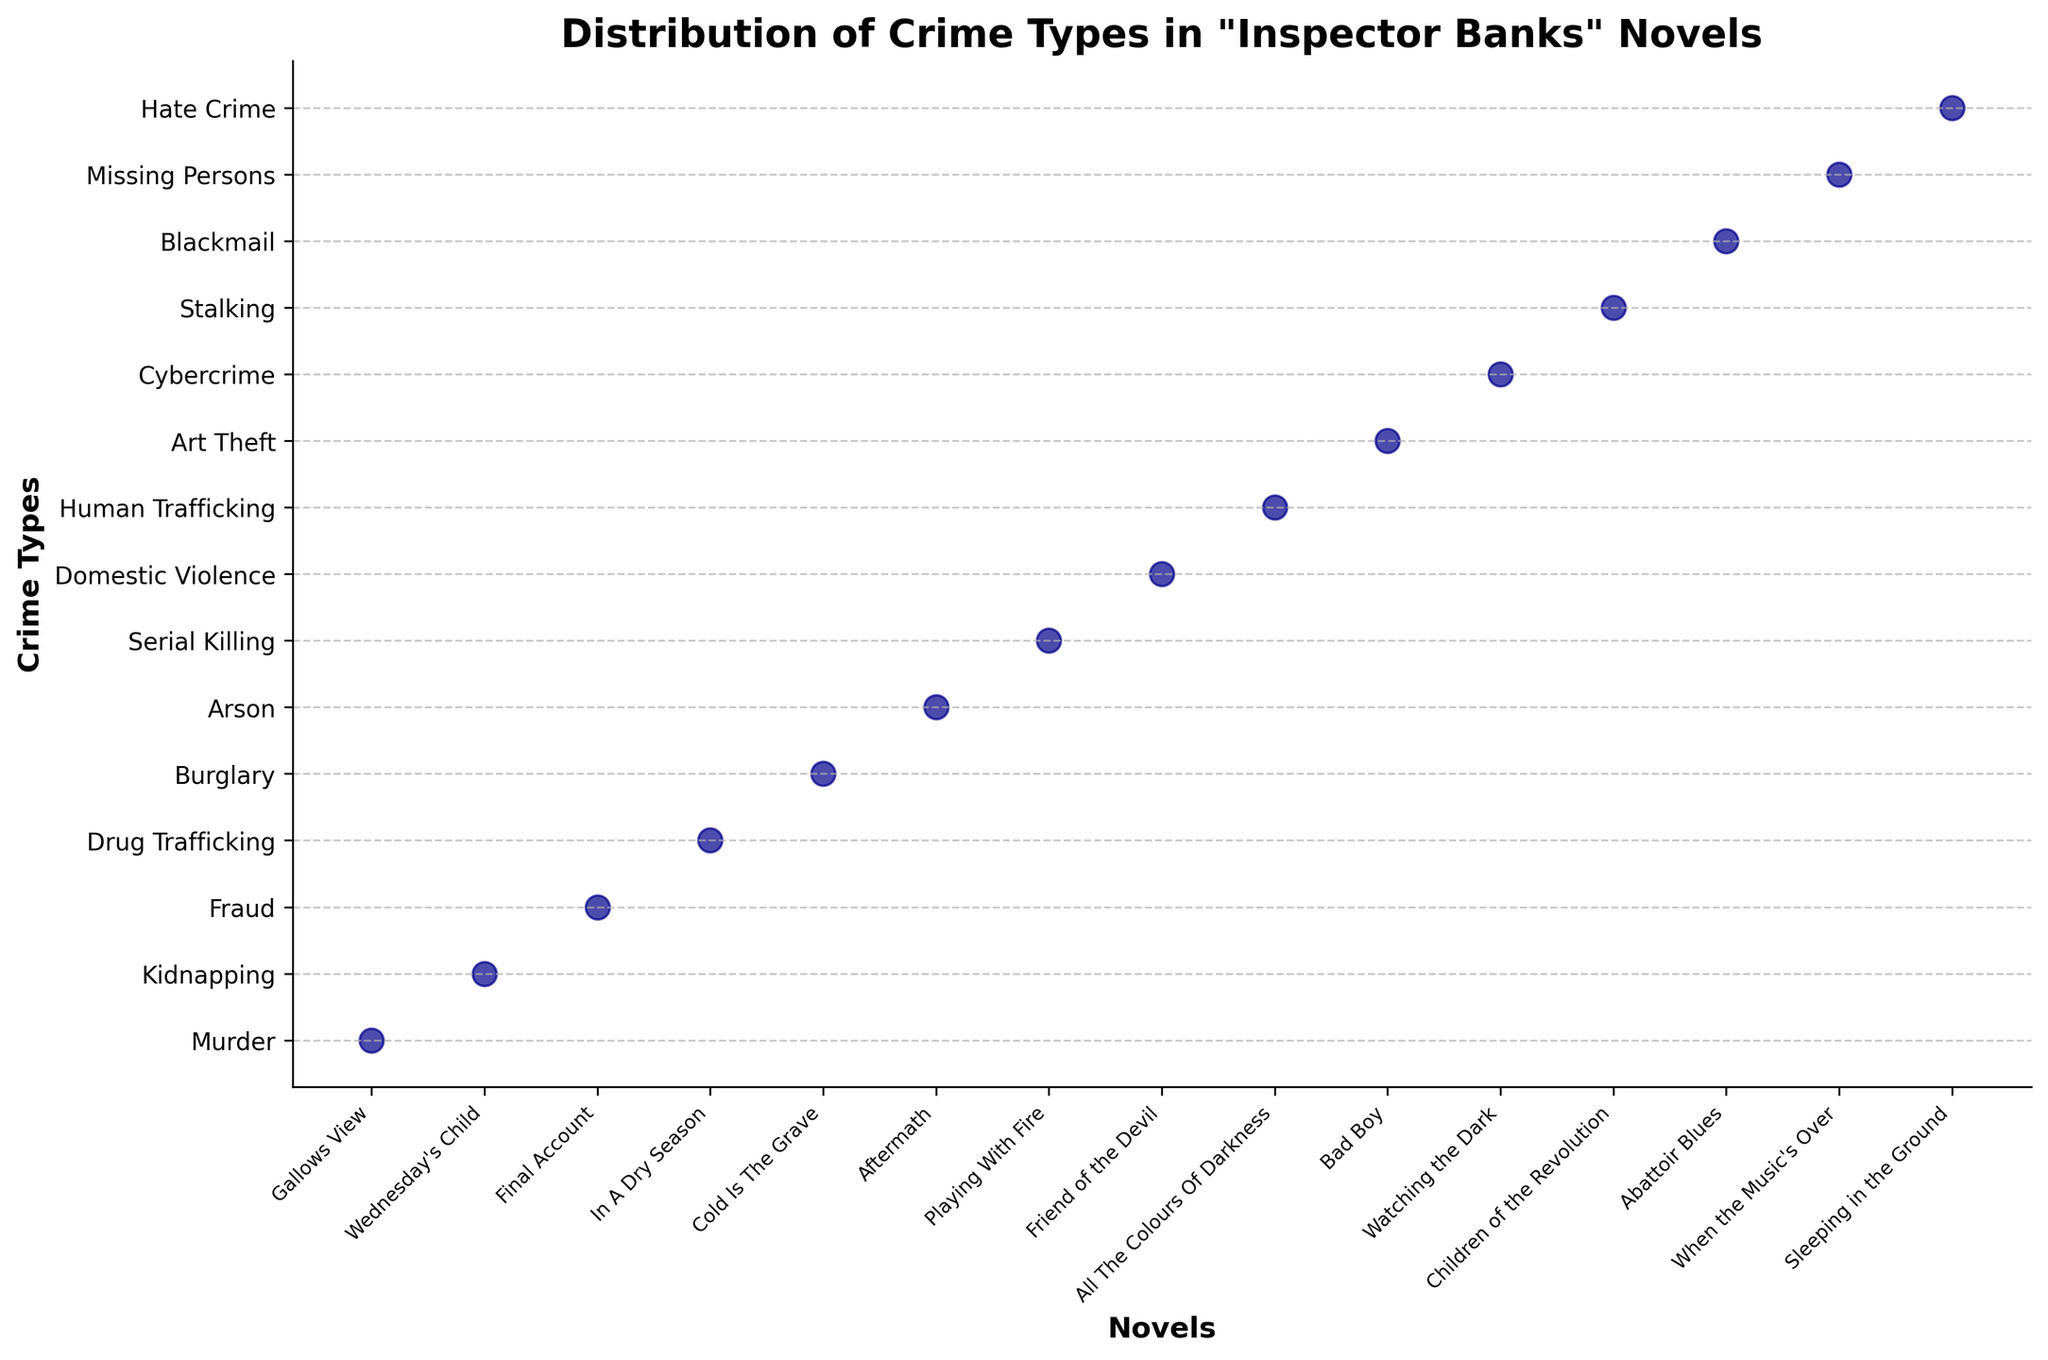What's the title of the figure? The title of the figure is usually located at the top center of the chart.
Answer: Distribution of Crime Types in "Inspector Banks" Novels How many crime types are depicted in the figure? To determine the number of crime types, count the ticks and labels on the y-axis.
Answer: 15 Which novel features the crime type "Arson"? Find the "Arson" label on the y-axis and trace it horizontally to the dot that indicates the novel title.
Answer: Aftermath What crime does the novel "Friend of the Devil" deal with? Locate the "Friend of the Devil" label on the x-axis and then trace it vertically to the corresponding crime type on the y-axis.
Answer: Domestic Violence Which crime type is shown immediately above "Fraud"? Identify the position of "Fraud" on the y-axis, then look at the next crime type above it.
Answer: Kidnapping Are there any novels that feature cyber-related crimes? Search for cyber-related terms in the crime types listed on the y-axis, then check if any corresponding novel titles are marked.
Answer: Yes, Watching the Dark features Cybercrime Which novel is associated with the most complex crimes based on its title? Complexity can be subjective, but generally, serial crimes are often seen as complex. Look for "Serial Killing" crime type on the y-axis and note its novel.
Answer: Playing With Fire Between "Wednesday's Child" and "Cold Is The Grave," which novel deals with a less severe crime? Compare the crime types: Kidnapping vs Burglary. Kidnapping is often seen as more severe than Burglary.
Answer: Cold Is The Grave Do any novels deal with more than one crime type based on this figure? Evaluate if there's a distribution discrepancy, but the strip plot indicates one crime type per novel, so none are duplicated.
Answer: No In the figure, which crime type is depicted at the lowest y-axis position? Look at the bottom-most label on the y-axis to identify the crime type.
Answer: Hate Crime 